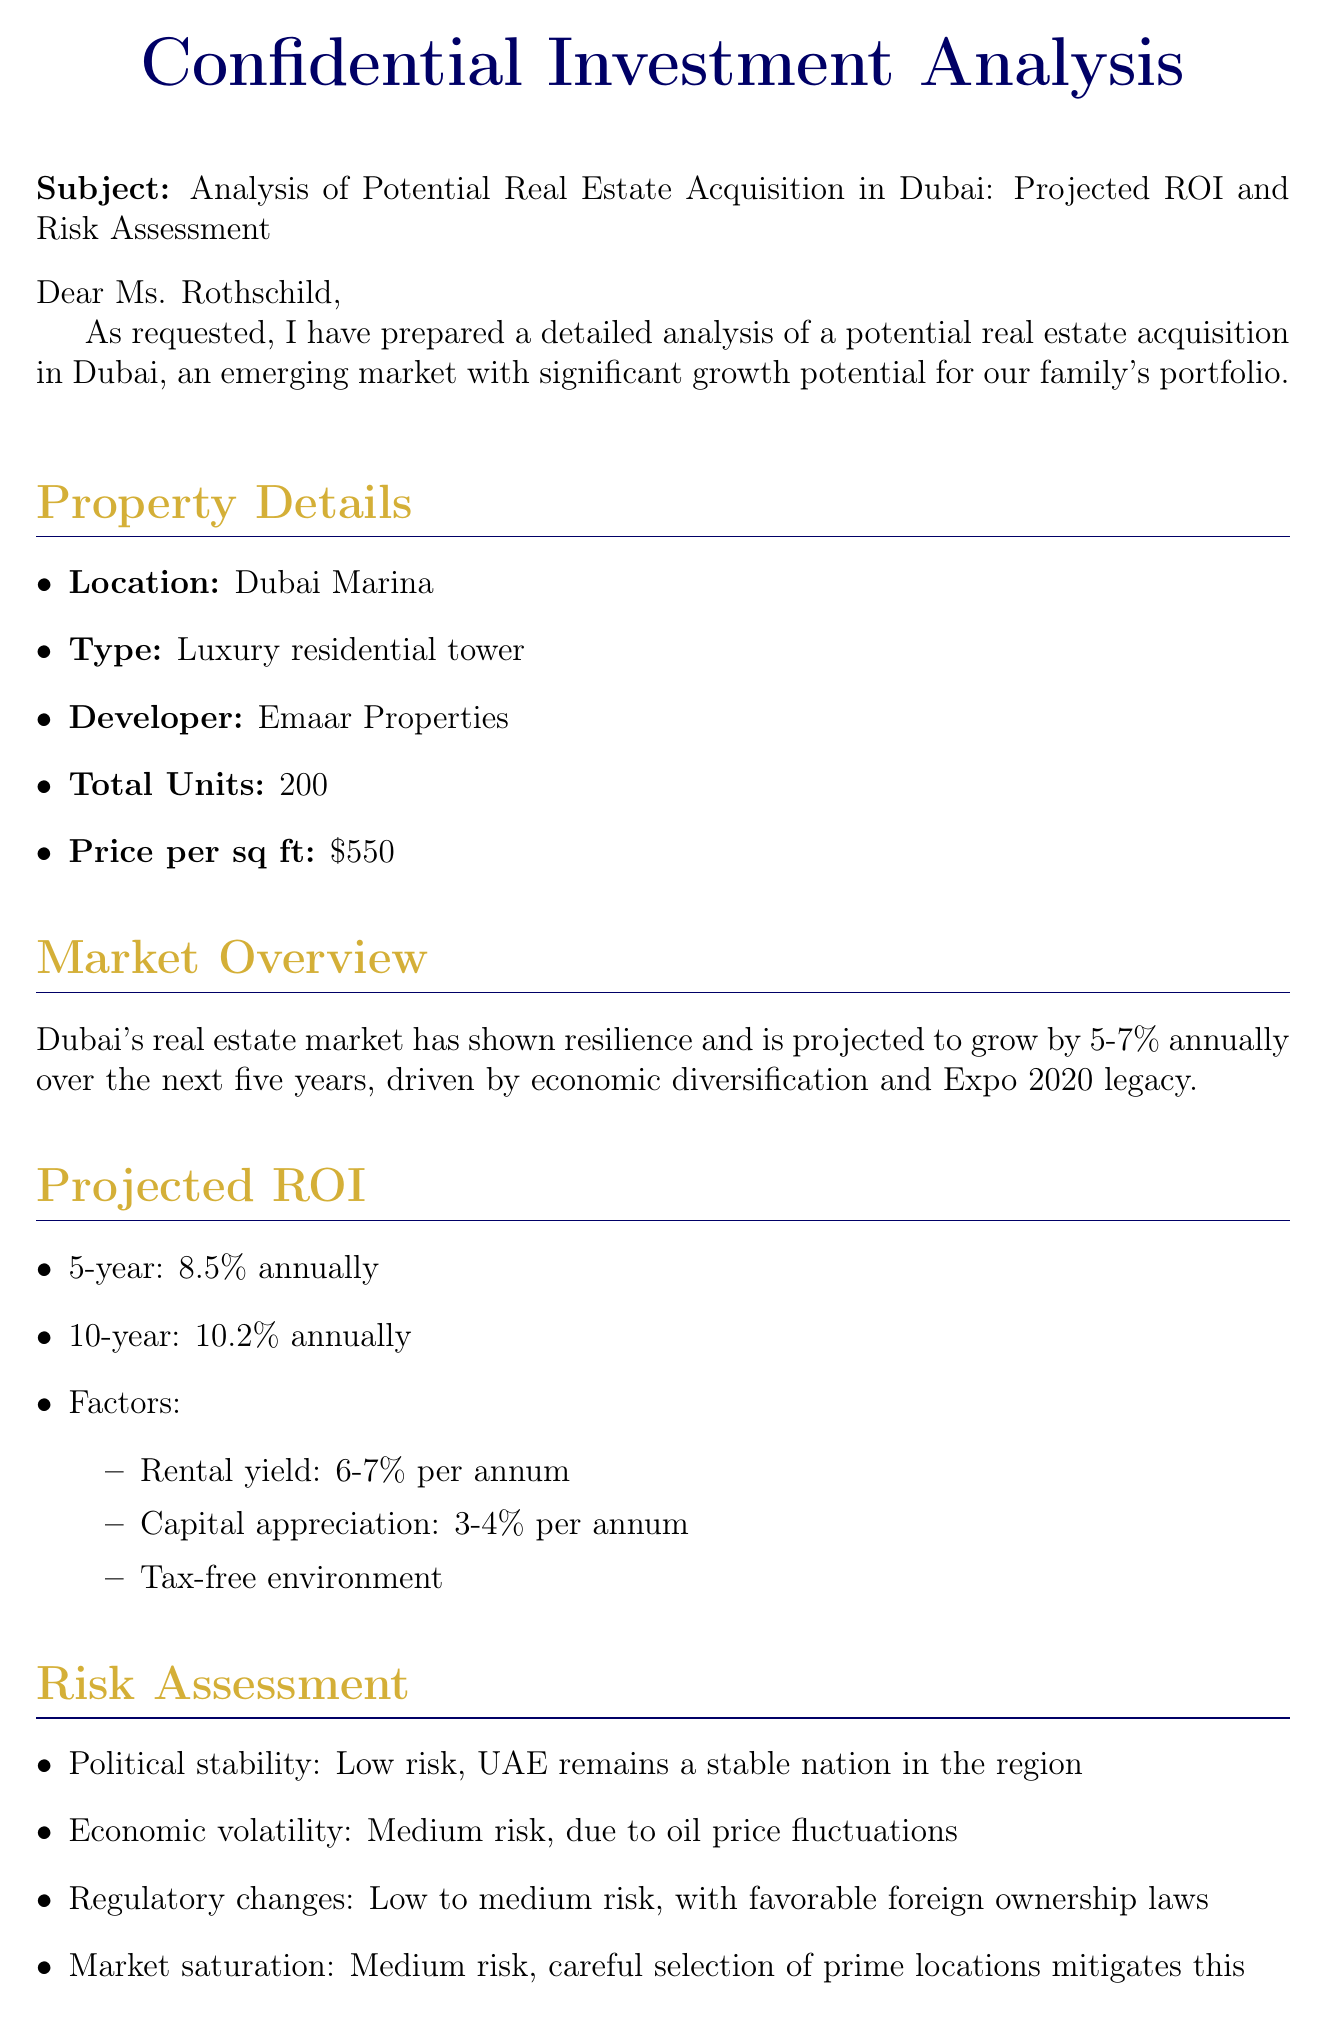What is the location of the property? The document lists Dubai Marina as the location of the property.
Answer: Dubai Marina Who is the developer of the property? The analysis mentions Emaar Properties as the developer.
Answer: Emaar Properties What is the projected 10-year ROI? The projected ROI for 10 years is specified in the document as 10.2% annually.
Answer: 10.2% annually What is the total number of units in the luxury residential tower? The document states that there are 200 total units in the property.
Answer: 200 What are the factors contributing to the projected ROI? The analysis lists three factors influencing ROI: rental yield, capital appreciation, and tax-free environment.
Answer: Rental yield, capital appreciation, tax-free environment What is the medium risk factor mentioned in the risk assessment? The document indicates economic volatility as a medium risk factor due to oil price fluctuations.
Answer: Economic volatility What strategy does this acquisition align with? The email specifies that this acquisition aligns with the family’s wealth preservation strategy.
Answer: Wealth preservation strategy What is the first next step suggested? The document states that engaging local legal counsel for due diligence is the first step.
Answer: Engage local legal counsel for due diligence 